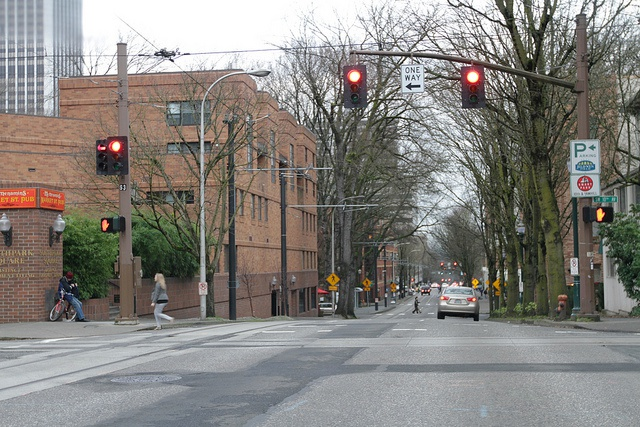Describe the objects in this image and their specific colors. I can see car in gray, darkgray, black, and lightgray tones, traffic light in gray, purple, black, and maroon tones, traffic light in gray, black, maroon, brown, and white tones, traffic light in gray, black, maroon, and ivory tones, and people in gray, darkgray, and black tones in this image. 